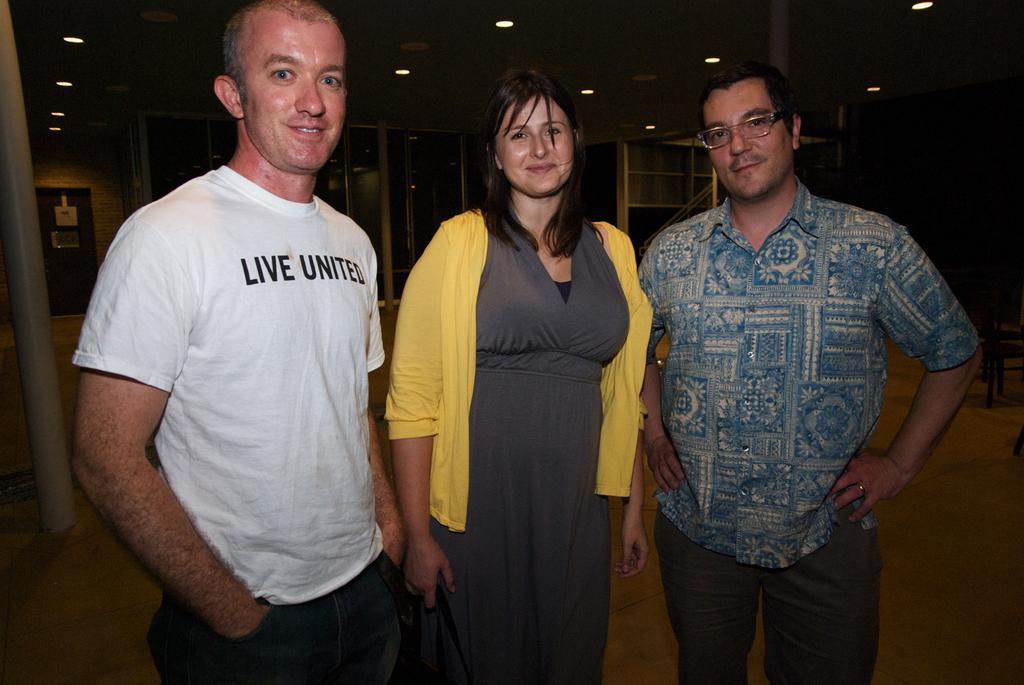In one or two sentences, can you explain what this image depicts? In the image we can see there are people standing on the floor. Behind there are racks and there is a door. There are lights on the roof. 